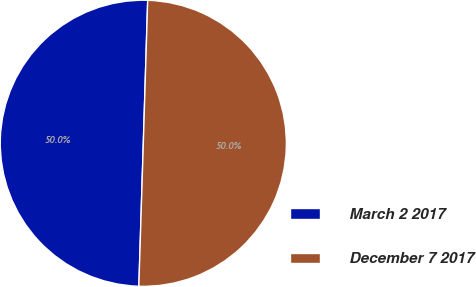<chart> <loc_0><loc_0><loc_500><loc_500><pie_chart><fcel>March 2 2017<fcel>December 7 2017<nl><fcel>49.99%<fcel>50.01%<nl></chart> 